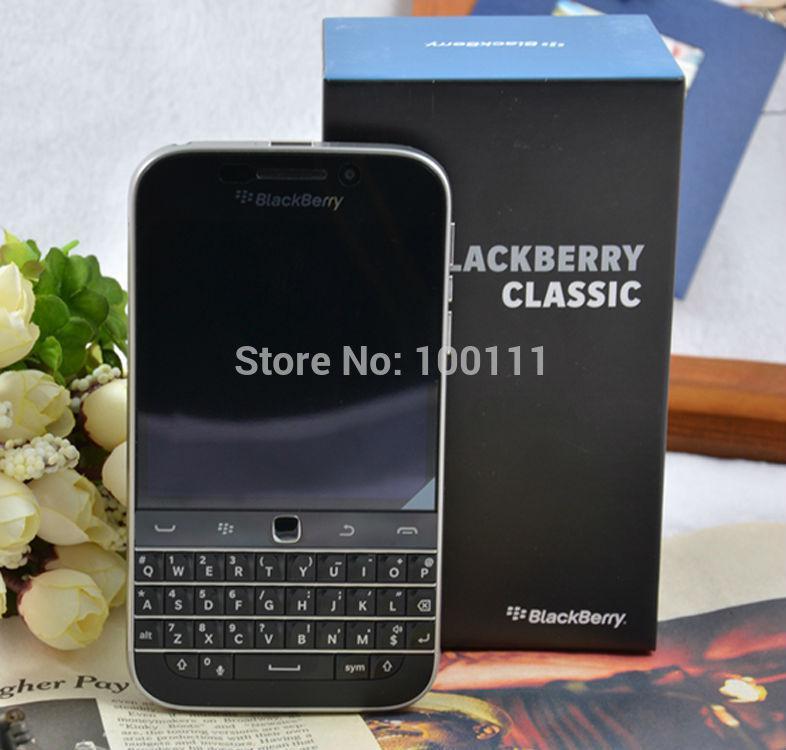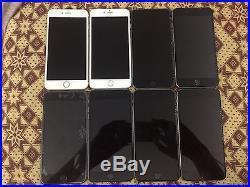The first image is the image on the left, the second image is the image on the right. Assess this claim about the two images: "The right image contains two horizontal rows of cell phones.". Correct or not? Answer yes or no. Yes. The first image is the image on the left, the second image is the image on the right. Evaluate the accuracy of this statement regarding the images: "Cell phones are lined in two lines on a surface in the image on the right.". Is it true? Answer yes or no. Yes. 